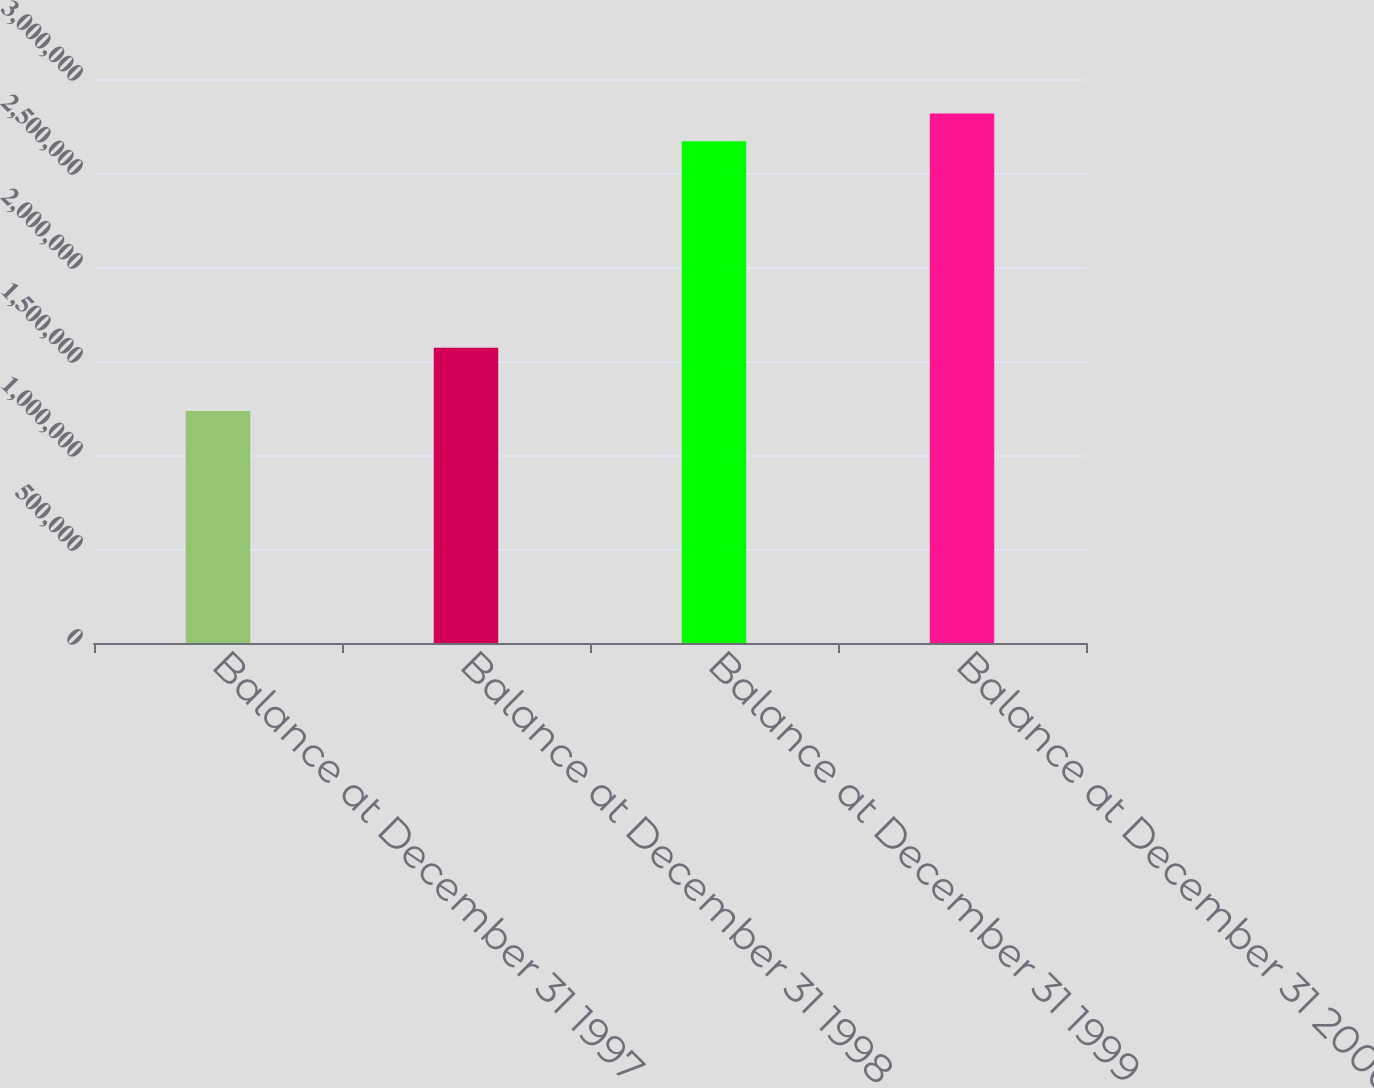<chart> <loc_0><loc_0><loc_500><loc_500><bar_chart><fcel>Balance at December 31 1997<fcel>Balance at December 31 1998<fcel>Balance at December 31 1999<fcel>Balance at December 31 2000<nl><fcel>1.23468e+06<fcel>1.57011e+06<fcel>2.6686e+06<fcel>2.81642e+06<nl></chart> 